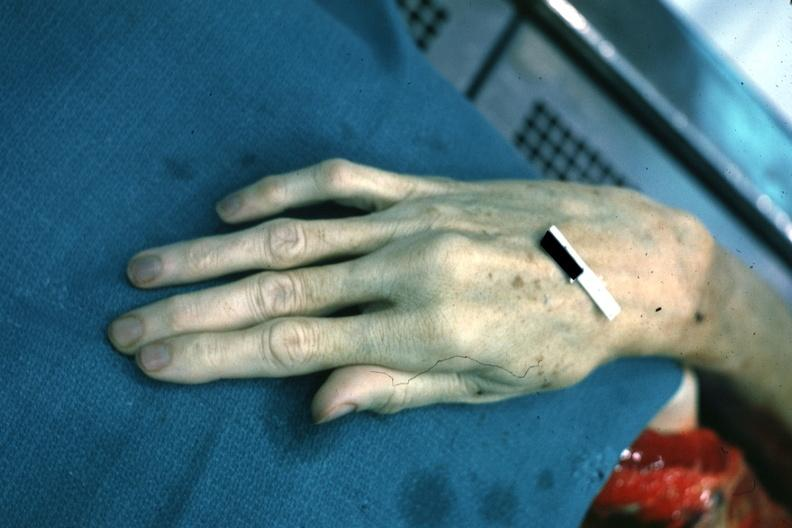does this image show dead typical very long fingers?
Answer the question using a single word or phrase. Yes 